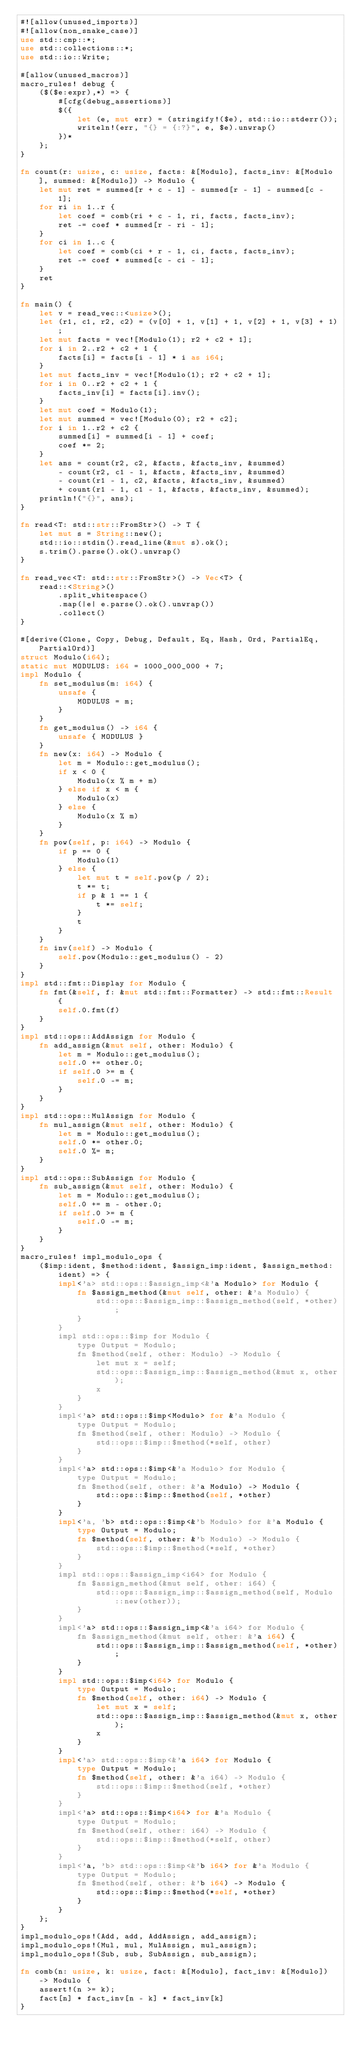Convert code to text. <code><loc_0><loc_0><loc_500><loc_500><_Rust_>#![allow(unused_imports)]
#![allow(non_snake_case)]
use std::cmp::*;
use std::collections::*;
use std::io::Write;

#[allow(unused_macros)]
macro_rules! debug {
    ($($e:expr),*) => {
        #[cfg(debug_assertions)]
        $({
            let (e, mut err) = (stringify!($e), std::io::stderr());
            writeln!(err, "{} = {:?}", e, $e).unwrap()
        })*
    };
}

fn count(r: usize, c: usize, facts: &[Modulo], facts_inv: &[Modulo], summed: &[Modulo]) -> Modulo {
    let mut ret = summed[r + c - 1] - summed[r - 1] - summed[c - 1];
    for ri in 1..r {
        let coef = comb(ri + c - 1, ri, facts, facts_inv);
        ret -= coef * summed[r - ri - 1];
    }
    for ci in 1..c {
        let coef = comb(ci + r - 1, ci, facts, facts_inv);
        ret -= coef * summed[c - ci - 1];
    }
    ret
}

fn main() {
    let v = read_vec::<usize>();
    let (r1, c1, r2, c2) = (v[0] + 1, v[1] + 1, v[2] + 1, v[3] + 1);
    let mut facts = vec![Modulo(1); r2 + c2 + 1];
    for i in 2..r2 + c2 + 1 {
        facts[i] = facts[i - 1] * i as i64;
    }
    let mut facts_inv = vec![Modulo(1); r2 + c2 + 1];
    for i in 0..r2 + c2 + 1 {
        facts_inv[i] = facts[i].inv();
    }
    let mut coef = Modulo(1);
    let mut summed = vec![Modulo(0); r2 + c2];
    for i in 1..r2 + c2 {
        summed[i] = summed[i - 1] + coef;
        coef *= 2;
    }
    let ans = count(r2, c2, &facts, &facts_inv, &summed)
        - count(r2, c1 - 1, &facts, &facts_inv, &summed)
        - count(r1 - 1, c2, &facts, &facts_inv, &summed)
        + count(r1 - 1, c1 - 1, &facts, &facts_inv, &summed);
    println!("{}", ans);
}

fn read<T: std::str::FromStr>() -> T {
    let mut s = String::new();
    std::io::stdin().read_line(&mut s).ok();
    s.trim().parse().ok().unwrap()
}

fn read_vec<T: std::str::FromStr>() -> Vec<T> {
    read::<String>()
        .split_whitespace()
        .map(|e| e.parse().ok().unwrap())
        .collect()
}

#[derive(Clone, Copy, Debug, Default, Eq, Hash, Ord, PartialEq, PartialOrd)]
struct Modulo(i64);
static mut MODULUS: i64 = 1000_000_000 + 7;
impl Modulo {
    fn set_modulus(m: i64) {
        unsafe {
            MODULUS = m;
        }
    }
    fn get_modulus() -> i64 {
        unsafe { MODULUS }
    }
    fn new(x: i64) -> Modulo {
        let m = Modulo::get_modulus();
        if x < 0 {
            Modulo(x % m + m)
        } else if x < m {
            Modulo(x)
        } else {
            Modulo(x % m)
        }
    }
    fn pow(self, p: i64) -> Modulo {
        if p == 0 {
            Modulo(1)
        } else {
            let mut t = self.pow(p / 2);
            t *= t;
            if p & 1 == 1 {
                t *= self;
            }
            t
        }
    }
    fn inv(self) -> Modulo {
        self.pow(Modulo::get_modulus() - 2)
    }
}
impl std::fmt::Display for Modulo {
    fn fmt(&self, f: &mut std::fmt::Formatter) -> std::fmt::Result {
        self.0.fmt(f)
    }
}
impl std::ops::AddAssign for Modulo {
    fn add_assign(&mut self, other: Modulo) {
        let m = Modulo::get_modulus();
        self.0 += other.0;
        if self.0 >= m {
            self.0 -= m;
        }
    }
}
impl std::ops::MulAssign for Modulo {
    fn mul_assign(&mut self, other: Modulo) {
        let m = Modulo::get_modulus();
        self.0 *= other.0;
        self.0 %= m;
    }
}
impl std::ops::SubAssign for Modulo {
    fn sub_assign(&mut self, other: Modulo) {
        let m = Modulo::get_modulus();
        self.0 += m - other.0;
        if self.0 >= m {
            self.0 -= m;
        }
    }
}
macro_rules! impl_modulo_ops {
    ($imp:ident, $method:ident, $assign_imp:ident, $assign_method:ident) => {
        impl<'a> std::ops::$assign_imp<&'a Modulo> for Modulo {
            fn $assign_method(&mut self, other: &'a Modulo) {
                std::ops::$assign_imp::$assign_method(self, *other);
            }
        }
        impl std::ops::$imp for Modulo {
            type Output = Modulo;
            fn $method(self, other: Modulo) -> Modulo {
                let mut x = self;
                std::ops::$assign_imp::$assign_method(&mut x, other);
                x
            }
        }
        impl<'a> std::ops::$imp<Modulo> for &'a Modulo {
            type Output = Modulo;
            fn $method(self, other: Modulo) -> Modulo {
                std::ops::$imp::$method(*self, other)
            }
        }
        impl<'a> std::ops::$imp<&'a Modulo> for Modulo {
            type Output = Modulo;
            fn $method(self, other: &'a Modulo) -> Modulo {
                std::ops::$imp::$method(self, *other)
            }
        }
        impl<'a, 'b> std::ops::$imp<&'b Modulo> for &'a Modulo {
            type Output = Modulo;
            fn $method(self, other: &'b Modulo) -> Modulo {
                std::ops::$imp::$method(*self, *other)
            }
        }
        impl std::ops::$assign_imp<i64> for Modulo {
            fn $assign_method(&mut self, other: i64) {
                std::ops::$assign_imp::$assign_method(self, Modulo::new(other));
            }
        }
        impl<'a> std::ops::$assign_imp<&'a i64> for Modulo {
            fn $assign_method(&mut self, other: &'a i64) {
                std::ops::$assign_imp::$assign_method(self, *other);
            }
        }
        impl std::ops::$imp<i64> for Modulo {
            type Output = Modulo;
            fn $method(self, other: i64) -> Modulo {
                let mut x = self;
                std::ops::$assign_imp::$assign_method(&mut x, other);
                x
            }
        }
        impl<'a> std::ops::$imp<&'a i64> for Modulo {
            type Output = Modulo;
            fn $method(self, other: &'a i64) -> Modulo {
                std::ops::$imp::$method(self, *other)
            }
        }
        impl<'a> std::ops::$imp<i64> for &'a Modulo {
            type Output = Modulo;
            fn $method(self, other: i64) -> Modulo {
                std::ops::$imp::$method(*self, other)
            }
        }
        impl<'a, 'b> std::ops::$imp<&'b i64> for &'a Modulo {
            type Output = Modulo;
            fn $method(self, other: &'b i64) -> Modulo {
                std::ops::$imp::$method(*self, *other)
            }
        }
    };
}
impl_modulo_ops!(Add, add, AddAssign, add_assign);
impl_modulo_ops!(Mul, mul, MulAssign, mul_assign);
impl_modulo_ops!(Sub, sub, SubAssign, sub_assign);

fn comb(n: usize, k: usize, fact: &[Modulo], fact_inv: &[Modulo]) -> Modulo {
    assert!(n >= k);
    fact[n] * fact_inv[n - k] * fact_inv[k]
}
</code> 